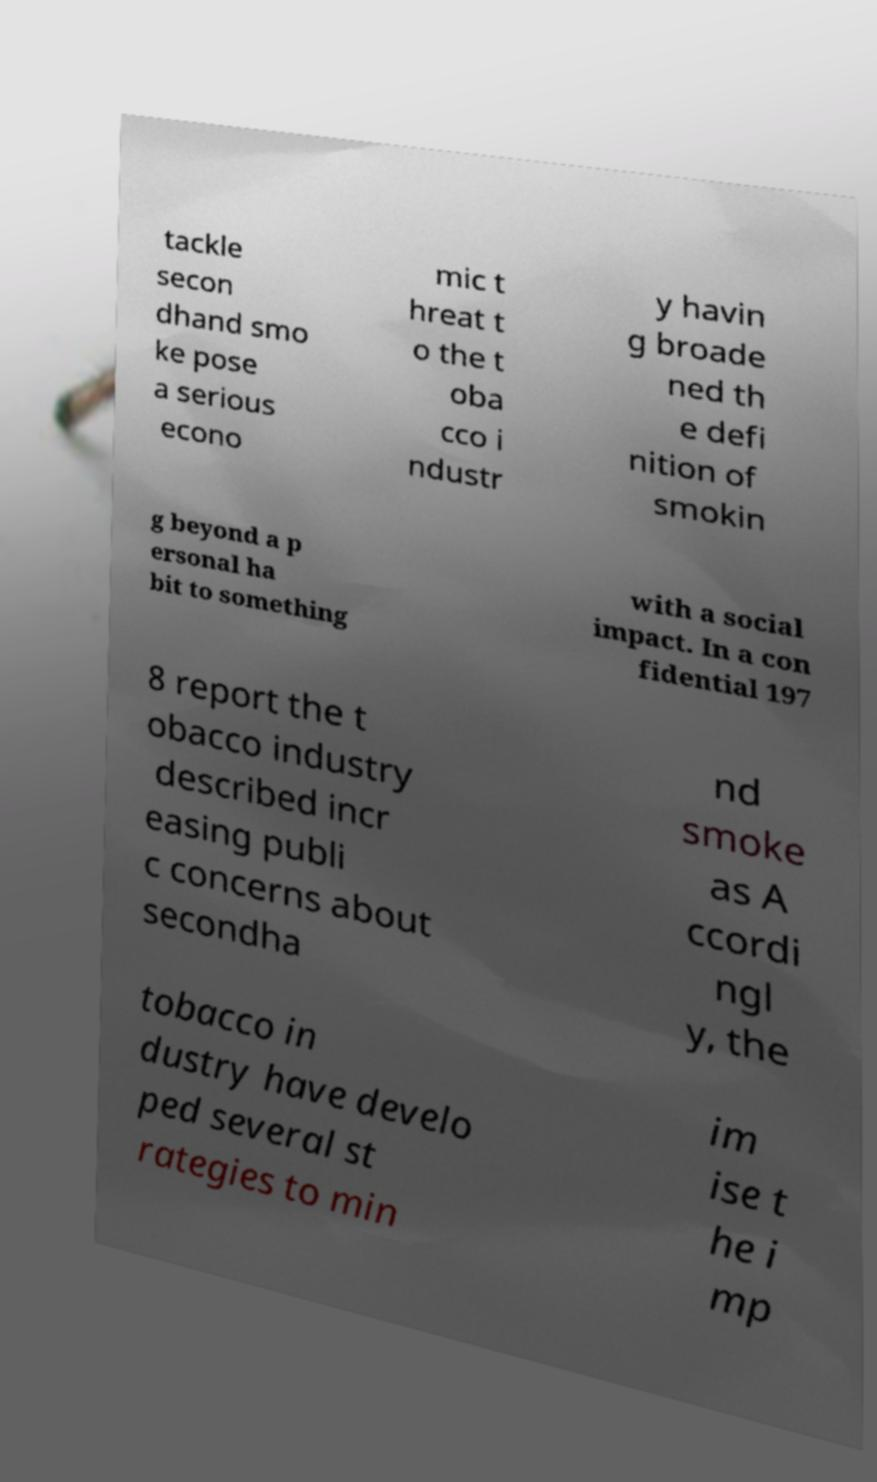Can you read and provide the text displayed in the image?This photo seems to have some interesting text. Can you extract and type it out for me? tackle secon dhand smo ke pose a serious econo mic t hreat t o the t oba cco i ndustr y havin g broade ned th e defi nition of smokin g beyond a p ersonal ha bit to something with a social impact. In a con fidential 197 8 report the t obacco industry described incr easing publi c concerns about secondha nd smoke as A ccordi ngl y, the tobacco in dustry have develo ped several st rategies to min im ise t he i mp 